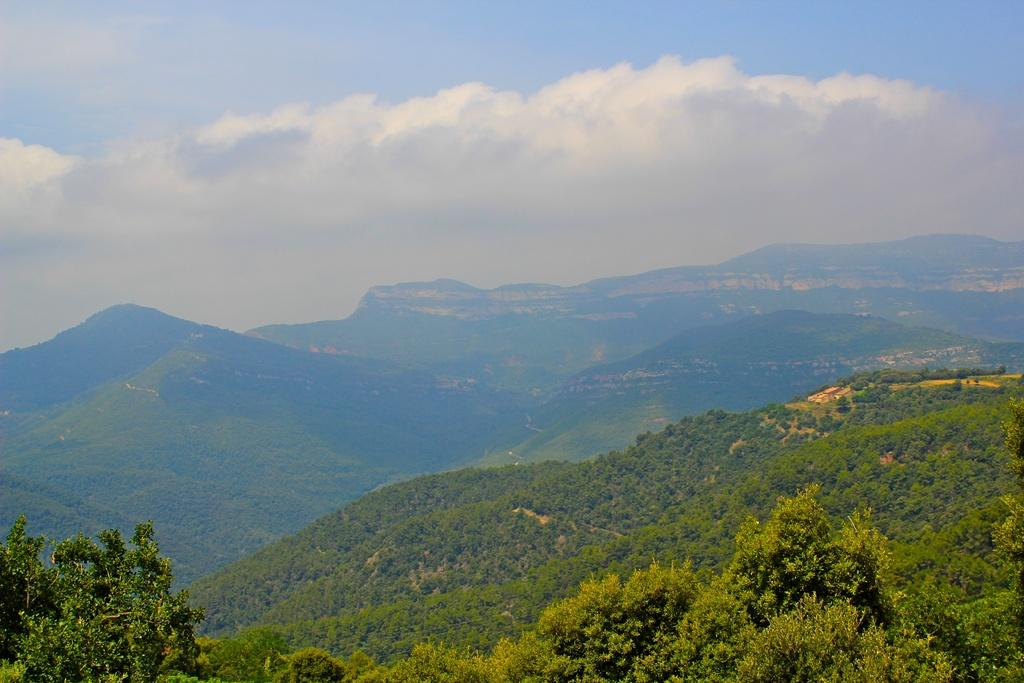What type of vegetation can be seen on the mountain in the image? There are plants and trees on the mountain in the image. Can you describe the landscape in the background of the image? There are mountains in the background of the image. What is visible in the sky in the image? There are clouds in the sky, and the sky is blue. What type of gold can be seen in the image? There is no gold present in the image. What songs are being sung by the plants on the mountain? Plants do not sing songs, so this cannot be answered from the image. 